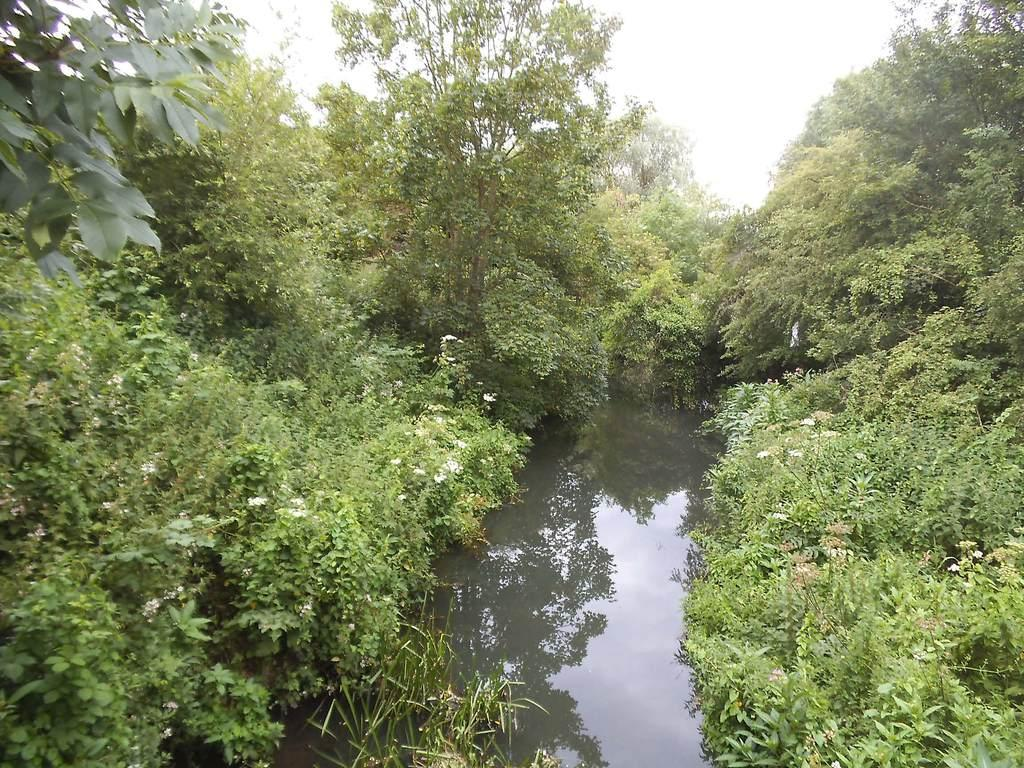What is the main feature of the image? There is water in the image. What can be seen around the water? There are trees around the water. What is the color of the trees? The trees are green in color. What other elements can be seen in the image? There are flowers in the image. What is the color of the flowers? The flowers are white in color. What is visible in the background of the image? The sky is visible in the background of the image. What type of coil is being used to start the party in the image? There is no party or coil present in the image. 